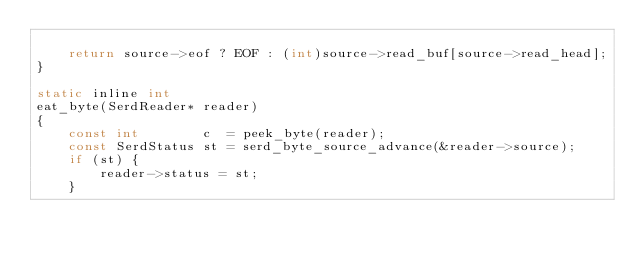Convert code to text. <code><loc_0><loc_0><loc_500><loc_500><_C_>
	return source->eof ? EOF : (int)source->read_buf[source->read_head];
}

static inline int
eat_byte(SerdReader* reader)
{
	const int        c  = peek_byte(reader);
	const SerdStatus st = serd_byte_source_advance(&reader->source);
	if (st) {
		reader->status = st;
	}</code> 